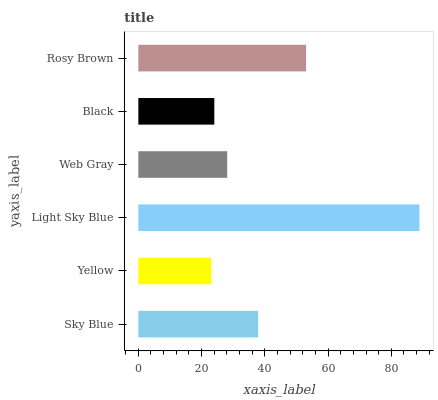Is Yellow the minimum?
Answer yes or no. Yes. Is Light Sky Blue the maximum?
Answer yes or no. Yes. Is Light Sky Blue the minimum?
Answer yes or no. No. Is Yellow the maximum?
Answer yes or no. No. Is Light Sky Blue greater than Yellow?
Answer yes or no. Yes. Is Yellow less than Light Sky Blue?
Answer yes or no. Yes. Is Yellow greater than Light Sky Blue?
Answer yes or no. No. Is Light Sky Blue less than Yellow?
Answer yes or no. No. Is Sky Blue the high median?
Answer yes or no. Yes. Is Web Gray the low median?
Answer yes or no. Yes. Is Rosy Brown the high median?
Answer yes or no. No. Is Black the low median?
Answer yes or no. No. 